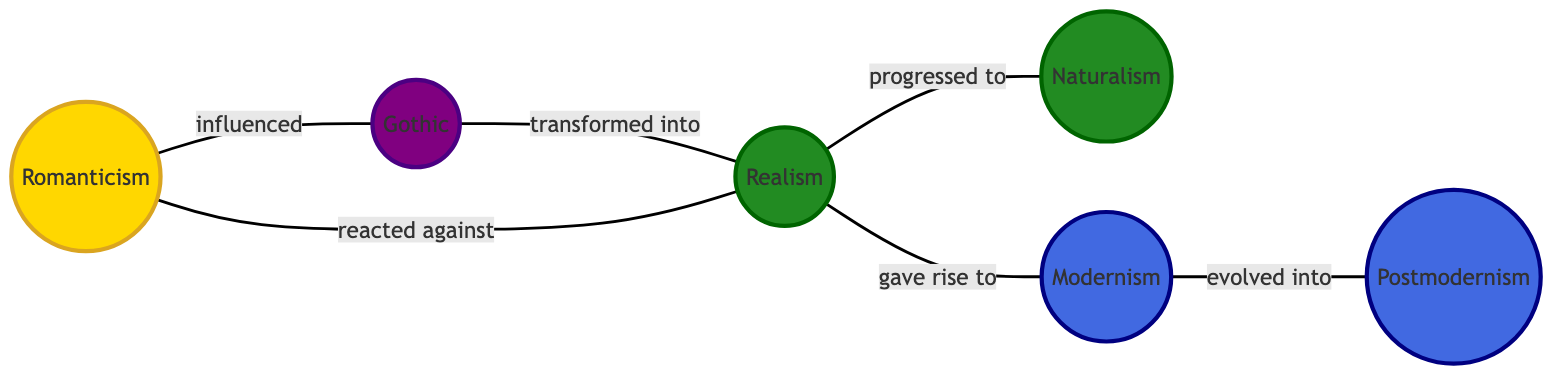What is the total number of nodes in the diagram? By counting the distinct literary movements listed in the nodes section, there are six: Romanticism, Gothic, Realism, Naturalism, Modernism, and Postmodernism.
Answer: 6 What is the relationship between Gothic and Realism? The edge labeled "transformed into" connects Gothic to Realism, indicating that Gothic transformed into Realism.
Answer: transformed into Which literary movement progressed to Naturalism? The edge labeled "progressed to" connects Realism to Naturalism, signifying that Realism progressed to Naturalism.
Answer: Realism How many relationships does Romanticism have with other movements? Romanticism is connected to Gothic (influenced), Realism (reacted against), so it has two edges.
Answer: 2 Which two movements directly connect Realism and Modernism? The edges from Realism to Naturalism (progressed to) and from Realism to Modernism (gave rise to) indicate that both Naturalism and Modernism are directly connected to Realism.
Answer: Naturalism, Modernism What movement did Modernism evolve into? The edge labeled "evolved into" connects Modernism to Postmodernism, showing that Modernism evolved into Postmodernism.
Answer: Postmodernism How does Romanticism relate to Realism? Romanticism is connected to Realism with the edge labeled "reacted against," indicating a reaction between the two movements.
Answer: reacted against What is the relationship label between Gothic and Romanticism? The edge labeled "influenced" connects Gothic to Romanticism, suggesting that Gothic influenced Romanticism.
Answer: influenced Which literary movement has a direct lineage from Realism? From the diagram, Realism directly connects to Naturalism (progressed to) and Modernism (gave rise to), indicating that both Naturalism and Modernism have a direct lineage from Realism.
Answer: Naturalism, Modernism 